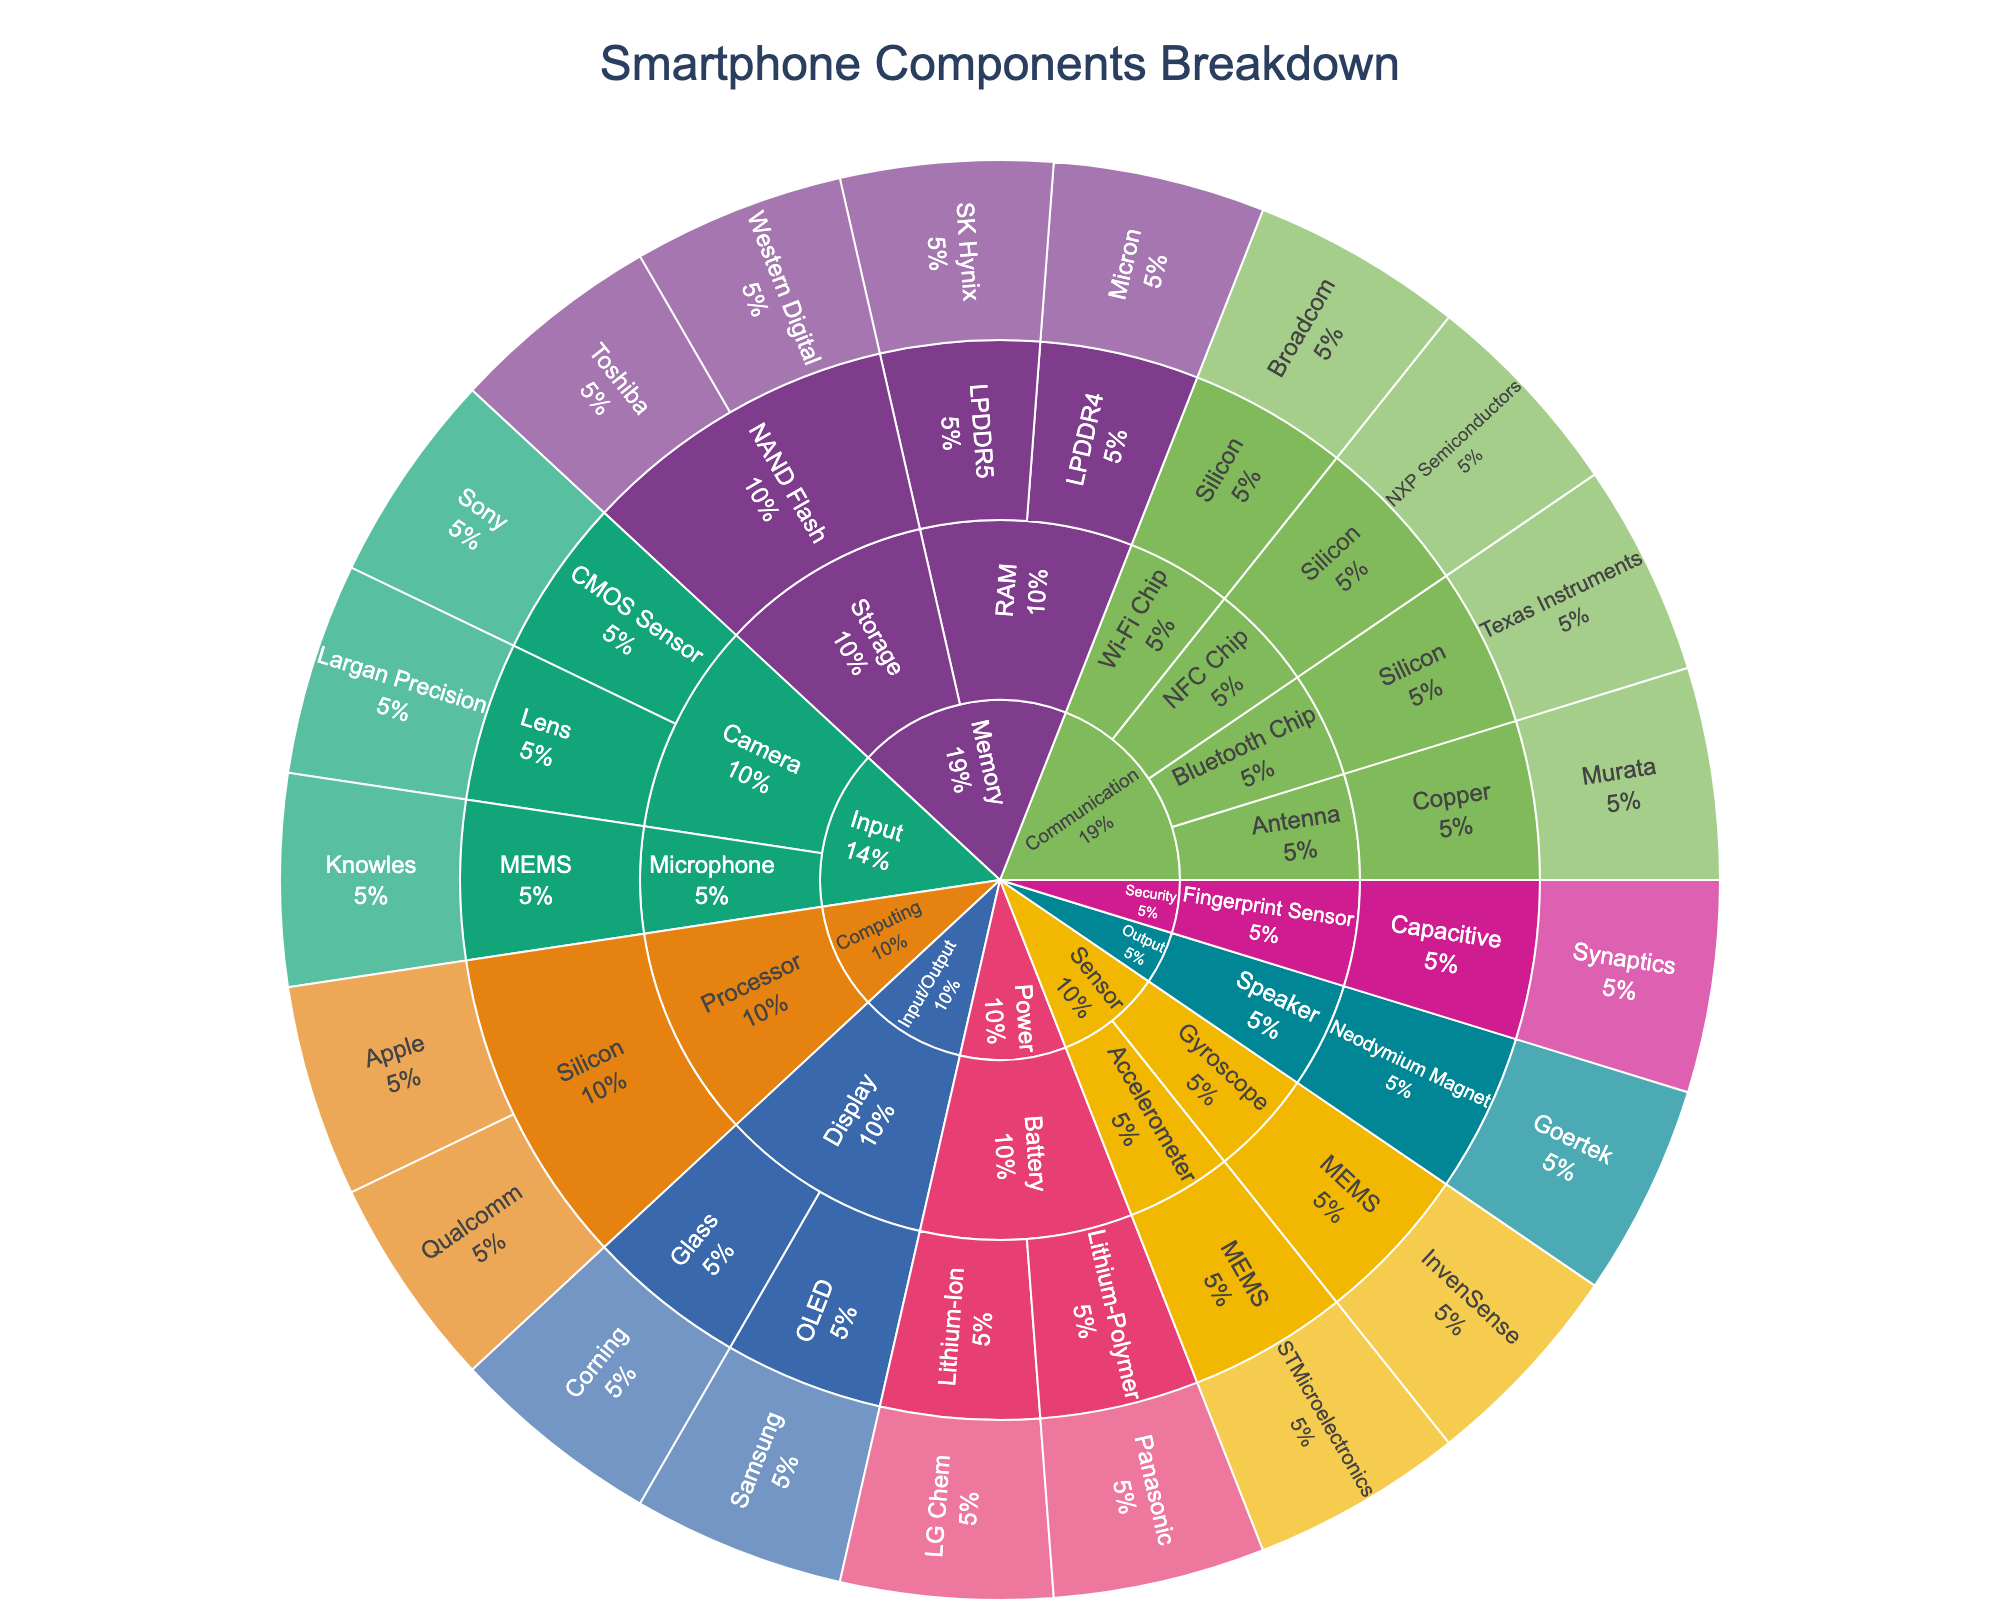What is the title of the Sunburst Plot? The title of the chart is displayed at the top and signifies what the chart represents.
Answer: Smartphone Components Breakdown Which manufacturer makes the Display component using OLED material? Follow the path from 'Input/Output' > 'Display' > 'OLED' in the chart to find the manufacturer.
Answer: Samsung How many different components are categorized under the 'Memory' function? In the Sunburst Plot, locate the 'Memory' section and count its subdivisions, represented by different components.
Answer: 2 (RAM and Storage) Which component under the 'Power' function has more types of materials listed? Navigate to the 'Power' function and compare the components Battery and their material categories.
Answer: Battery What percentage share does the 'Communication' function hold in the overall structure? Look at the size of the 'Communication' segment in the Sunburst Plot and check its percentage representation.
Answer: (exact percentage from plot, e.g., 20%) Which manufacturer is associated with the 'Fingerprint Sensor' in the plot? Follow the path from 'Security' > 'Fingerprint Sensor' and check the manufacturer listed.
Answer: Synaptics Are there more different components under 'Input' or 'Output' functions? Compare the number of different components listed under the 'Input' and 'Output' function segments in the plot.
Answer: Input Which component in 'Sensor' uses MEMS material and who manufactures it? Locate the 'Sensor' section and follow the path to the MEMS material to see the associated manufacturer(s).
Answer: Accelerometer – STMicroelectronics, Gyroscope – InvenSense What function has the highest diversity in component materials? Examine each function in the Sunburst Plot and compare the diversity of materials listed under each to determine the one with the most varied materials.
Answer: (function name with most materials) How many components are made using silicon as the material? Identify and count all the components across different functions in the plot that list 'Silicon' as their material.
Answer: 4 (Processor, Wi-Fi Chip, Bluetooth Chip, NFC Chip) 